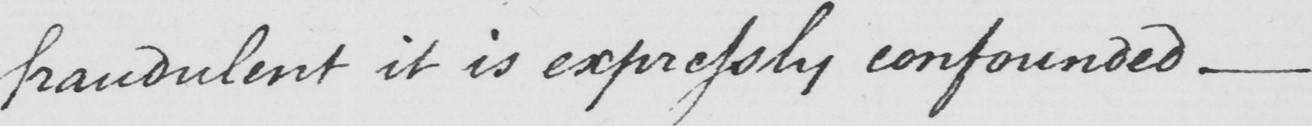What is written in this line of handwriting? fraudulent it is expressly confounded  _ 